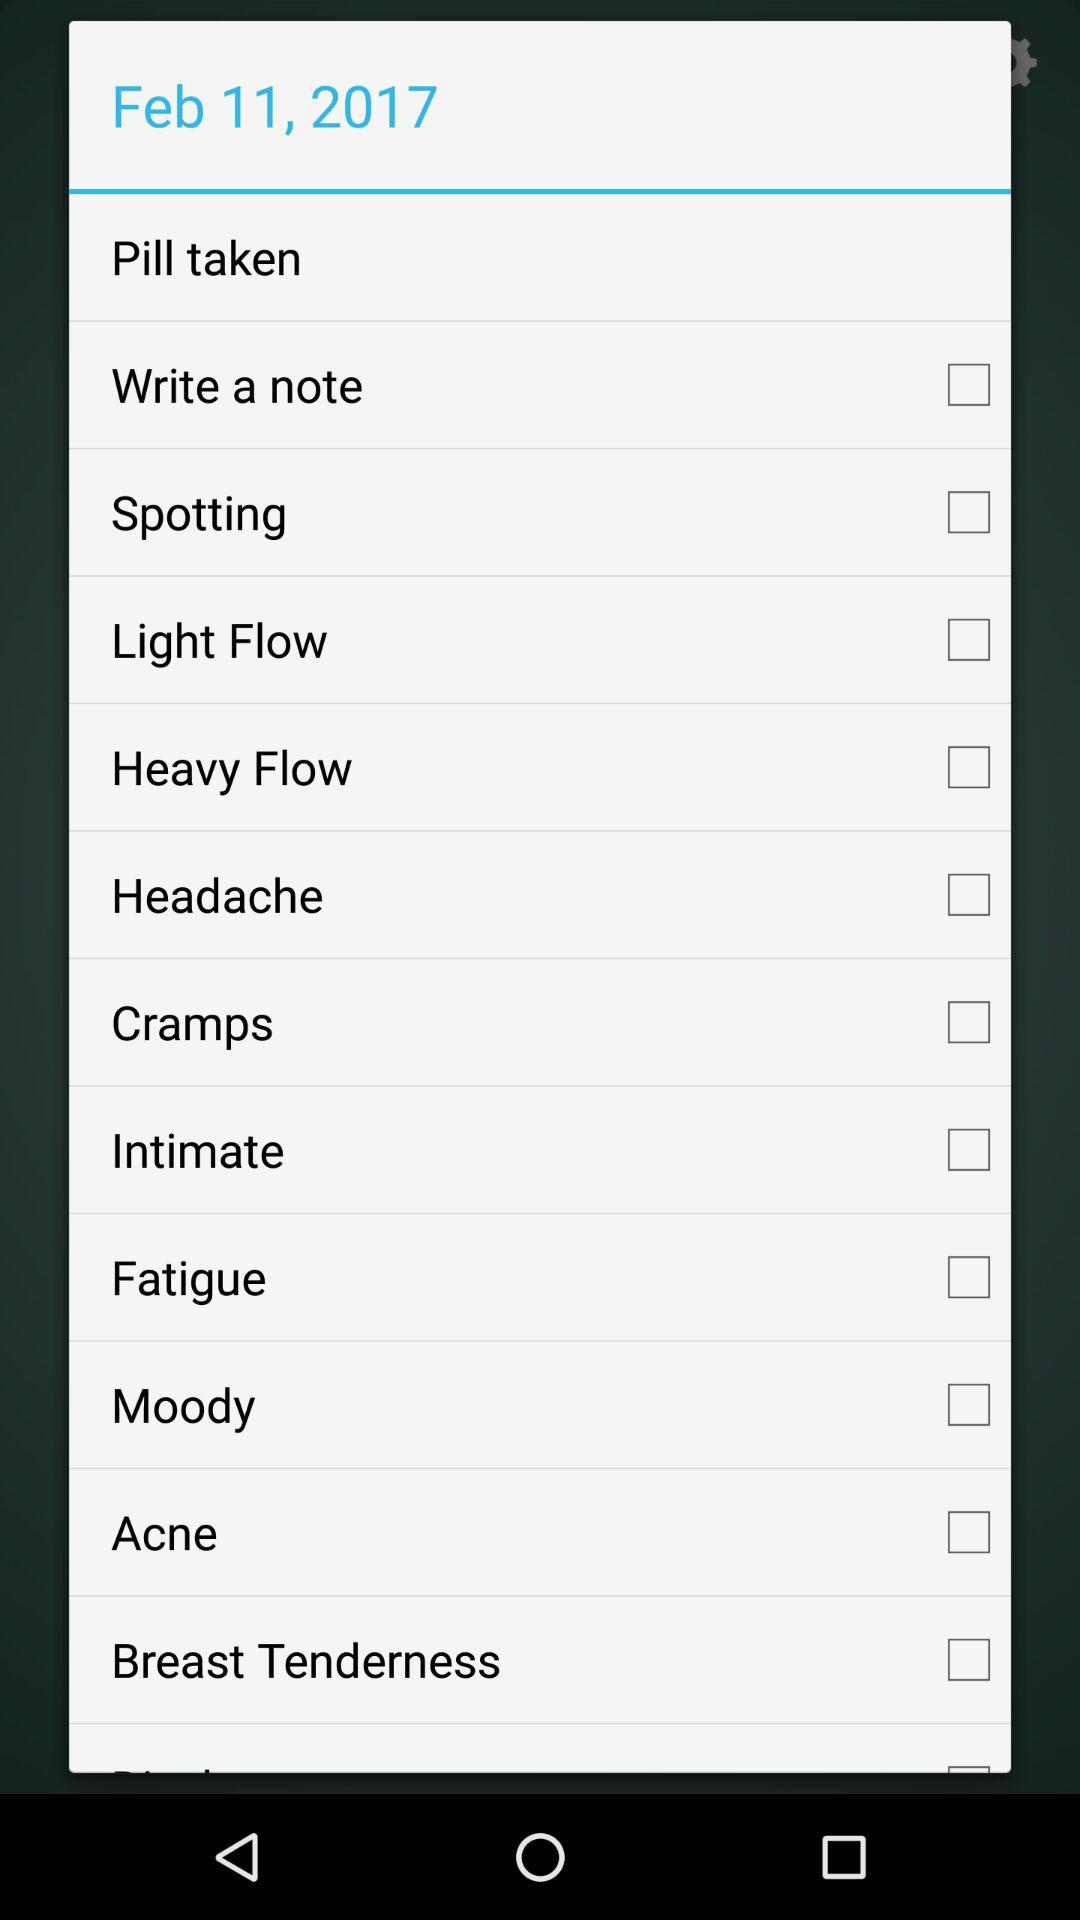What is the given date? The given date is February 11, 2017. 